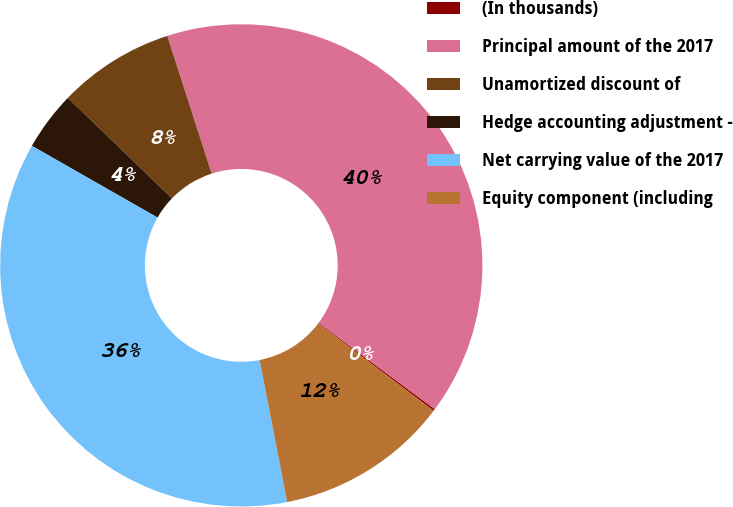Convert chart. <chart><loc_0><loc_0><loc_500><loc_500><pie_chart><fcel>(In thousands)<fcel>Principal amount of the 2017<fcel>Unamortized discount of<fcel>Hedge accounting adjustment -<fcel>Net carrying value of the 2017<fcel>Equity component (including<nl><fcel>0.13%<fcel>40.14%<fcel>7.81%<fcel>3.97%<fcel>36.3%<fcel>11.65%<nl></chart> 